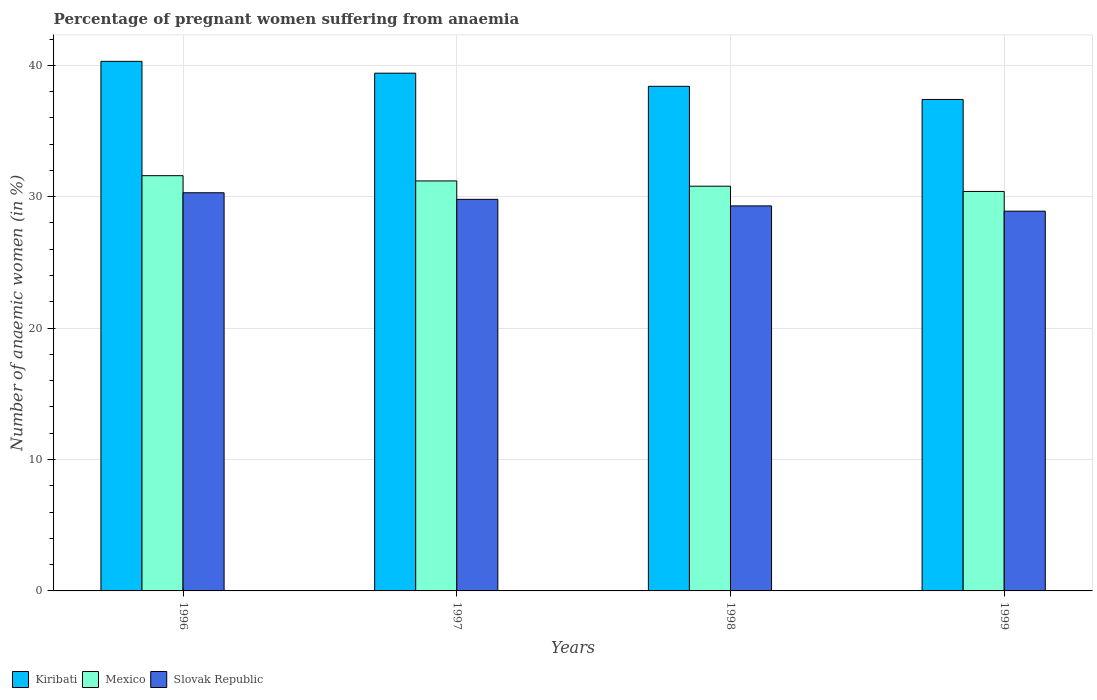How many groups of bars are there?
Provide a short and direct response. 4. Are the number of bars per tick equal to the number of legend labels?
Your answer should be very brief. Yes. Are the number of bars on each tick of the X-axis equal?
Make the answer very short. Yes. What is the label of the 2nd group of bars from the left?
Your answer should be very brief. 1997. In how many cases, is the number of bars for a given year not equal to the number of legend labels?
Provide a succinct answer. 0. What is the number of anaemic women in Slovak Republic in 1999?
Offer a terse response. 28.9. Across all years, what is the maximum number of anaemic women in Kiribati?
Your answer should be very brief. 40.3. Across all years, what is the minimum number of anaemic women in Mexico?
Ensure brevity in your answer.  30.4. In which year was the number of anaemic women in Kiribati maximum?
Ensure brevity in your answer.  1996. What is the total number of anaemic women in Slovak Republic in the graph?
Provide a short and direct response. 118.3. What is the difference between the number of anaemic women in Kiribati in 1996 and that in 1999?
Give a very brief answer. 2.9. What is the difference between the number of anaemic women in Slovak Republic in 1997 and the number of anaemic women in Kiribati in 1999?
Offer a terse response. -7.6. What is the average number of anaemic women in Mexico per year?
Make the answer very short. 31. In how many years, is the number of anaemic women in Kiribati greater than 6 %?
Your response must be concise. 4. What is the ratio of the number of anaemic women in Mexico in 1997 to that in 1998?
Offer a terse response. 1.01. Is the difference between the number of anaemic women in Slovak Republic in 1997 and 1999 greater than the difference between the number of anaemic women in Kiribati in 1997 and 1999?
Ensure brevity in your answer.  No. What is the difference between the highest and the second highest number of anaemic women in Kiribati?
Provide a short and direct response. 0.9. What is the difference between the highest and the lowest number of anaemic women in Slovak Republic?
Provide a short and direct response. 1.4. What does the 1st bar from the left in 1998 represents?
Provide a succinct answer. Kiribati. What does the 1st bar from the right in 1996 represents?
Your answer should be compact. Slovak Republic. Is it the case that in every year, the sum of the number of anaemic women in Kiribati and number of anaemic women in Mexico is greater than the number of anaemic women in Slovak Republic?
Provide a succinct answer. Yes. How many bars are there?
Your answer should be very brief. 12. Are all the bars in the graph horizontal?
Your answer should be compact. No. How many years are there in the graph?
Keep it short and to the point. 4. What is the difference between two consecutive major ticks on the Y-axis?
Your answer should be very brief. 10. Does the graph contain grids?
Give a very brief answer. Yes. Where does the legend appear in the graph?
Offer a terse response. Bottom left. What is the title of the graph?
Your response must be concise. Percentage of pregnant women suffering from anaemia. What is the label or title of the X-axis?
Your answer should be compact. Years. What is the label or title of the Y-axis?
Ensure brevity in your answer.  Number of anaemic women (in %). What is the Number of anaemic women (in %) in Kiribati in 1996?
Your answer should be compact. 40.3. What is the Number of anaemic women (in %) in Mexico in 1996?
Your answer should be very brief. 31.6. What is the Number of anaemic women (in %) of Slovak Republic in 1996?
Your answer should be compact. 30.3. What is the Number of anaemic women (in %) in Kiribati in 1997?
Offer a terse response. 39.4. What is the Number of anaemic women (in %) in Mexico in 1997?
Provide a succinct answer. 31.2. What is the Number of anaemic women (in %) in Slovak Republic in 1997?
Provide a succinct answer. 29.8. What is the Number of anaemic women (in %) in Kiribati in 1998?
Provide a succinct answer. 38.4. What is the Number of anaemic women (in %) in Mexico in 1998?
Provide a succinct answer. 30.8. What is the Number of anaemic women (in %) in Slovak Republic in 1998?
Ensure brevity in your answer.  29.3. What is the Number of anaemic women (in %) of Kiribati in 1999?
Give a very brief answer. 37.4. What is the Number of anaemic women (in %) in Mexico in 1999?
Ensure brevity in your answer.  30.4. What is the Number of anaemic women (in %) of Slovak Republic in 1999?
Offer a very short reply. 28.9. Across all years, what is the maximum Number of anaemic women (in %) of Kiribati?
Your answer should be compact. 40.3. Across all years, what is the maximum Number of anaemic women (in %) of Mexico?
Ensure brevity in your answer.  31.6. Across all years, what is the maximum Number of anaemic women (in %) in Slovak Republic?
Keep it short and to the point. 30.3. Across all years, what is the minimum Number of anaemic women (in %) of Kiribati?
Your answer should be very brief. 37.4. Across all years, what is the minimum Number of anaemic women (in %) in Mexico?
Keep it short and to the point. 30.4. Across all years, what is the minimum Number of anaemic women (in %) in Slovak Republic?
Ensure brevity in your answer.  28.9. What is the total Number of anaemic women (in %) of Kiribati in the graph?
Your answer should be very brief. 155.5. What is the total Number of anaemic women (in %) in Mexico in the graph?
Provide a succinct answer. 124. What is the total Number of anaemic women (in %) in Slovak Republic in the graph?
Provide a short and direct response. 118.3. What is the difference between the Number of anaemic women (in %) in Kiribati in 1996 and that in 1997?
Offer a terse response. 0.9. What is the difference between the Number of anaemic women (in %) in Slovak Republic in 1996 and that in 1997?
Provide a succinct answer. 0.5. What is the difference between the Number of anaemic women (in %) of Kiribati in 1996 and that in 1998?
Give a very brief answer. 1.9. What is the difference between the Number of anaemic women (in %) of Slovak Republic in 1996 and that in 1998?
Make the answer very short. 1. What is the difference between the Number of anaemic women (in %) in Kiribati in 1996 and that in 1999?
Your answer should be very brief. 2.9. What is the difference between the Number of anaemic women (in %) in Mexico in 1996 and that in 1999?
Keep it short and to the point. 1.2. What is the difference between the Number of anaemic women (in %) of Slovak Republic in 1996 and that in 1999?
Offer a very short reply. 1.4. What is the difference between the Number of anaemic women (in %) in Kiribati in 1997 and that in 1998?
Keep it short and to the point. 1. What is the difference between the Number of anaemic women (in %) in Slovak Republic in 1997 and that in 1998?
Make the answer very short. 0.5. What is the difference between the Number of anaemic women (in %) of Kiribati in 1997 and that in 1999?
Offer a very short reply. 2. What is the difference between the Number of anaemic women (in %) in Slovak Republic in 1997 and that in 1999?
Your answer should be compact. 0.9. What is the difference between the Number of anaemic women (in %) of Mexico in 1998 and that in 1999?
Your answer should be very brief. 0.4. What is the difference between the Number of anaemic women (in %) of Kiribati in 1996 and the Number of anaemic women (in %) of Mexico in 1997?
Your answer should be very brief. 9.1. What is the difference between the Number of anaemic women (in %) in Kiribati in 1996 and the Number of anaemic women (in %) in Slovak Republic in 1997?
Make the answer very short. 10.5. What is the difference between the Number of anaemic women (in %) of Mexico in 1996 and the Number of anaemic women (in %) of Slovak Republic in 1997?
Your answer should be compact. 1.8. What is the difference between the Number of anaemic women (in %) in Kiribati in 1996 and the Number of anaemic women (in %) in Slovak Republic in 1998?
Give a very brief answer. 11. What is the difference between the Number of anaemic women (in %) in Mexico in 1996 and the Number of anaemic women (in %) in Slovak Republic in 1998?
Make the answer very short. 2.3. What is the difference between the Number of anaemic women (in %) of Kiribati in 1996 and the Number of anaemic women (in %) of Mexico in 1999?
Make the answer very short. 9.9. What is the difference between the Number of anaemic women (in %) of Mexico in 1996 and the Number of anaemic women (in %) of Slovak Republic in 1999?
Keep it short and to the point. 2.7. What is the difference between the Number of anaemic women (in %) of Kiribati in 1997 and the Number of anaemic women (in %) of Mexico in 1998?
Offer a very short reply. 8.6. What is the difference between the Number of anaemic women (in %) in Kiribati in 1998 and the Number of anaemic women (in %) in Mexico in 1999?
Your response must be concise. 8. What is the difference between the Number of anaemic women (in %) in Kiribati in 1998 and the Number of anaemic women (in %) in Slovak Republic in 1999?
Offer a terse response. 9.5. What is the average Number of anaemic women (in %) of Kiribati per year?
Give a very brief answer. 38.88. What is the average Number of anaemic women (in %) in Slovak Republic per year?
Your answer should be very brief. 29.57. In the year 1996, what is the difference between the Number of anaemic women (in %) in Kiribati and Number of anaemic women (in %) in Mexico?
Provide a succinct answer. 8.7. In the year 1996, what is the difference between the Number of anaemic women (in %) of Mexico and Number of anaemic women (in %) of Slovak Republic?
Your response must be concise. 1.3. In the year 1998, what is the difference between the Number of anaemic women (in %) in Kiribati and Number of anaemic women (in %) in Mexico?
Your response must be concise. 7.6. In the year 1998, what is the difference between the Number of anaemic women (in %) of Mexico and Number of anaemic women (in %) of Slovak Republic?
Provide a short and direct response. 1.5. In the year 1999, what is the difference between the Number of anaemic women (in %) in Mexico and Number of anaemic women (in %) in Slovak Republic?
Your answer should be very brief. 1.5. What is the ratio of the Number of anaemic women (in %) in Kiribati in 1996 to that in 1997?
Offer a very short reply. 1.02. What is the ratio of the Number of anaemic women (in %) of Mexico in 1996 to that in 1997?
Provide a succinct answer. 1.01. What is the ratio of the Number of anaemic women (in %) of Slovak Republic in 1996 to that in 1997?
Offer a terse response. 1.02. What is the ratio of the Number of anaemic women (in %) in Kiribati in 1996 to that in 1998?
Your response must be concise. 1.05. What is the ratio of the Number of anaemic women (in %) of Slovak Republic in 1996 to that in 1998?
Provide a short and direct response. 1.03. What is the ratio of the Number of anaemic women (in %) in Kiribati in 1996 to that in 1999?
Give a very brief answer. 1.08. What is the ratio of the Number of anaemic women (in %) of Mexico in 1996 to that in 1999?
Offer a very short reply. 1.04. What is the ratio of the Number of anaemic women (in %) of Slovak Republic in 1996 to that in 1999?
Provide a short and direct response. 1.05. What is the ratio of the Number of anaemic women (in %) in Kiribati in 1997 to that in 1998?
Offer a terse response. 1.03. What is the ratio of the Number of anaemic women (in %) in Slovak Republic in 1997 to that in 1998?
Provide a succinct answer. 1.02. What is the ratio of the Number of anaemic women (in %) of Kiribati in 1997 to that in 1999?
Give a very brief answer. 1.05. What is the ratio of the Number of anaemic women (in %) in Mexico in 1997 to that in 1999?
Ensure brevity in your answer.  1.03. What is the ratio of the Number of anaemic women (in %) of Slovak Republic in 1997 to that in 1999?
Offer a terse response. 1.03. What is the ratio of the Number of anaemic women (in %) of Kiribati in 1998 to that in 1999?
Your response must be concise. 1.03. What is the ratio of the Number of anaemic women (in %) of Mexico in 1998 to that in 1999?
Give a very brief answer. 1.01. What is the ratio of the Number of anaemic women (in %) in Slovak Republic in 1998 to that in 1999?
Provide a succinct answer. 1.01. What is the difference between the highest and the second highest Number of anaemic women (in %) in Mexico?
Make the answer very short. 0.4. What is the difference between the highest and the second highest Number of anaemic women (in %) of Slovak Republic?
Provide a short and direct response. 0.5. What is the difference between the highest and the lowest Number of anaemic women (in %) of Kiribati?
Provide a short and direct response. 2.9. What is the difference between the highest and the lowest Number of anaemic women (in %) in Slovak Republic?
Provide a short and direct response. 1.4. 